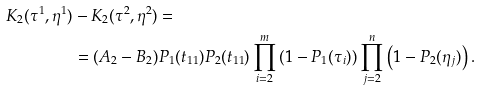<formula> <loc_0><loc_0><loc_500><loc_500>K _ { 2 } ( \tau ^ { 1 } , \eta ^ { 1 } ) & - K _ { 2 } ( \tau ^ { 2 } , \eta ^ { 2 } ) = \\ & = ( A _ { 2 } - B _ { 2 } ) P _ { 1 } ( t _ { 1 1 } ) P _ { 2 } ( t _ { 1 1 } ) \prod _ { i = 2 } ^ { m } \left ( 1 - P _ { 1 } ( \tau _ { i } ) \right ) \prod _ { j = 2 } ^ { n } \left ( 1 - P _ { 2 } ( \eta _ { j } ) \right ) .</formula> 